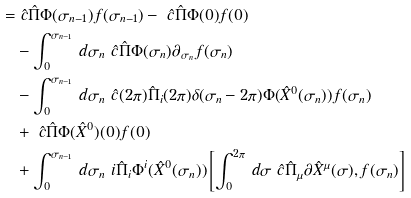Convert formula to latex. <formula><loc_0><loc_0><loc_500><loc_500>= & \ \hat { c } \hat { \Pi } \Phi ( \sigma _ { n - 1 } ) f ( \sigma _ { n - 1 } ) - \ \hat { c } \hat { \Pi } \Phi ( 0 ) f ( 0 ) \\ & - \int _ { 0 } ^ { \sigma _ { n - 1 } } \, d \sigma _ { n } \ \hat { c } \hat { \Pi } \Phi ( \sigma _ { n } ) \partial _ { \sigma _ { n } } f ( \sigma _ { n } ) \\ & - \int _ { 0 } ^ { \sigma _ { n - 1 } } \, d \sigma _ { n } \ \hat { c } ( 2 \pi ) \hat { \Pi } _ { i } ( 2 \pi ) \delta ( \sigma _ { n } - 2 \pi ) \Phi ( \hat { X } ^ { 0 } ( \sigma _ { n } ) ) f ( \sigma _ { n } ) \\ & + \ \hat { c } \hat { \Pi } \Phi ( \hat { X } ^ { 0 } ) ( 0 ) f ( 0 ) \\ & + \int _ { 0 } ^ { \sigma _ { n - 1 } } \, d \sigma _ { n } \ i \hat { \Pi } _ { i } \Phi ^ { i } ( \hat { X } ^ { 0 } ( \sigma _ { n } ) ) \left [ \int _ { 0 } ^ { 2 \pi } \, d \sigma \ \hat { c } \hat { \Pi } _ { \mu } \partial \hat { X } ^ { \mu } ( \sigma ) , f ( \sigma _ { n } ) \right ] \\</formula> 